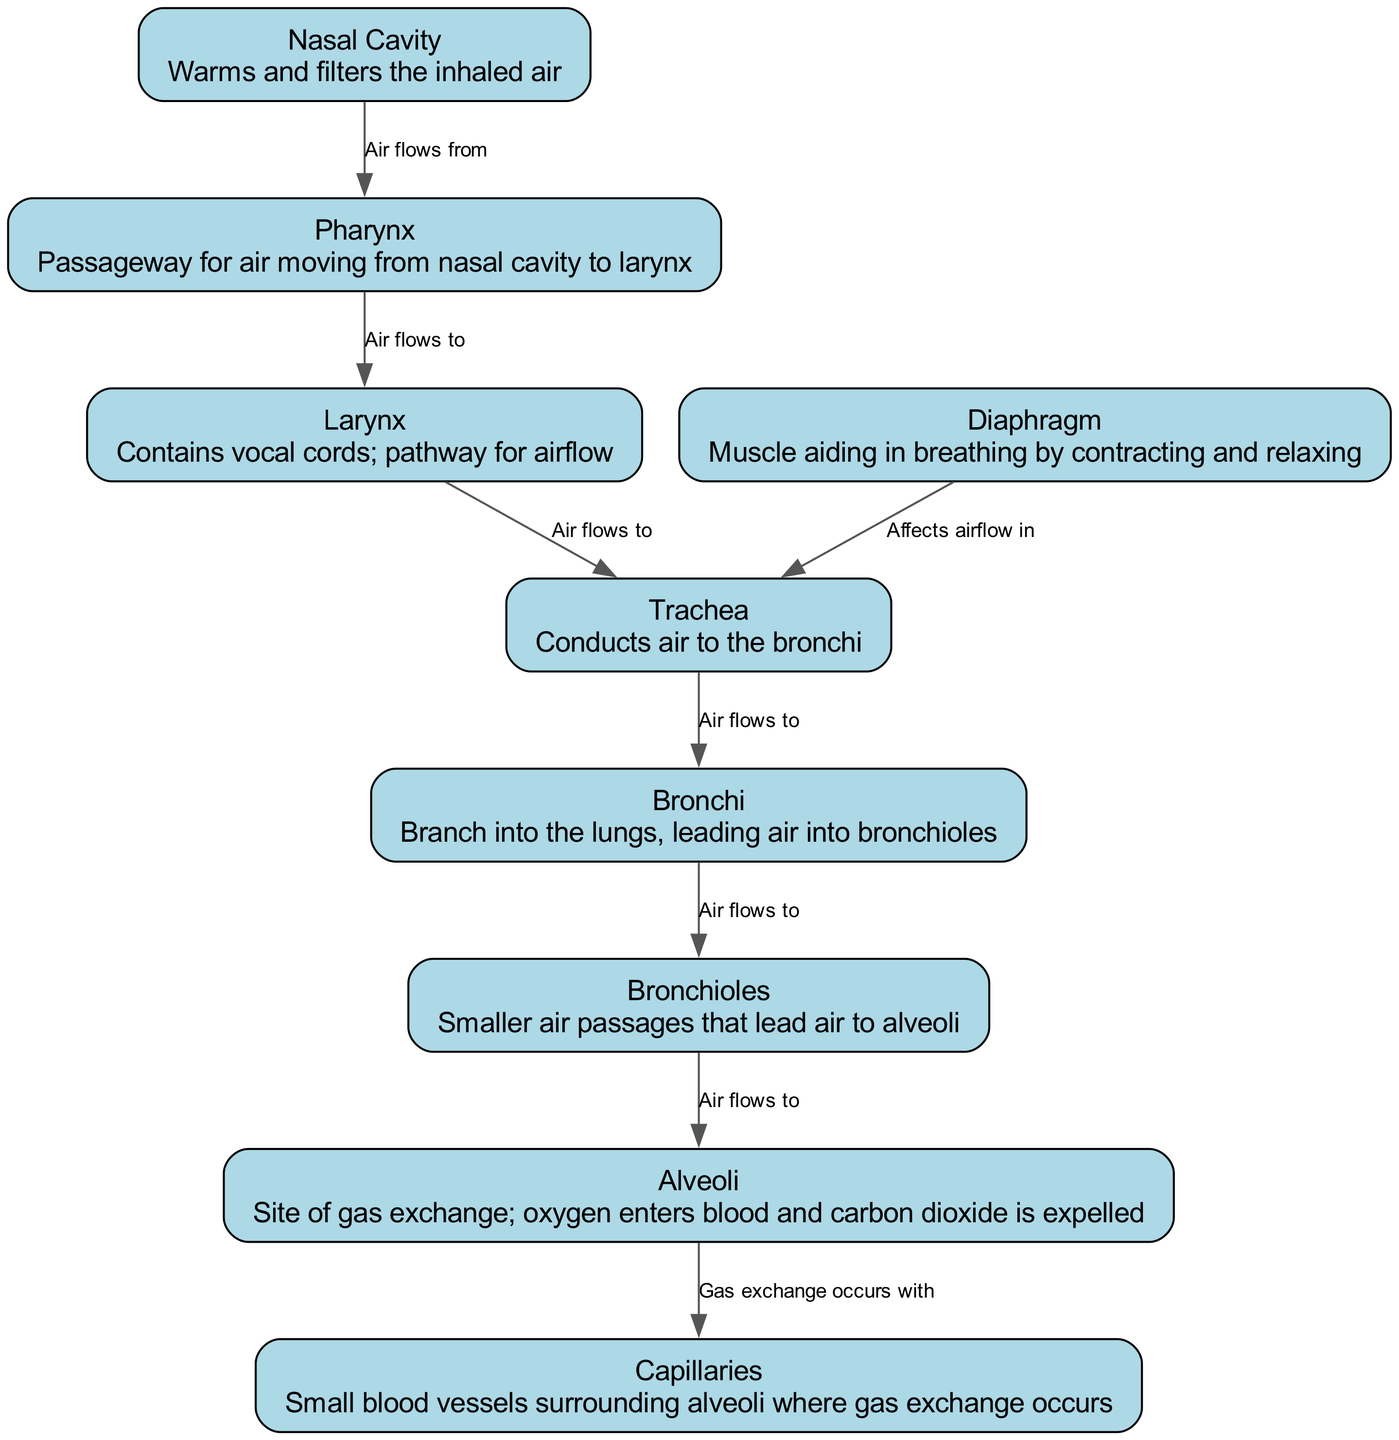What is the function of the Nasal Cavity? The Nasal Cavity's description states that it "warms and filters the inhaled air," which indicates its role in preparing air before it enters the respiratory system.
Answer: Warms and filters the inhaled air How many nodes are present in the diagram? The diagram lists a total of 9 nodes representing different parts of the respiratory system.
Answer: 9 What flows from the Pharynx to the Larynx? The diagram specifies that "air flows to" the Larynx from the Pharynx, indicating that air is the substance that transitions in this direction.
Answer: Air Where does gas exchange occur? According to the diagram, gas exchange occurs at the Alveoli, as it describes them as the "site of gas exchange."
Answer: Alveoli What muscle aids in breathing by contracting and relaxing? The diagram identifies the Diaphragm as the muscle that plays a significant role in the breathing process through its contraction and relaxation.
Answer: Diaphragm What is the relationship between Alveoli and Capillaries? The diagram states that gas exchange occurs with the Capillaries at the Alveoli, which highlights the direct functional relationship in the gas exchange process.
Answer: Gas exchange occurs with Which structure conducts air to the Bronchi? The diagram indicates that the Trachea is responsible for conducting air to the Bronchi, highlighting its role in the airflow pathway.
Answer: Trachea In what direction does air flow from the Bronchioles? The diagram illustrates that air flows from the Bronchioles to the Alveoli, indicating the pathway of air entering the gas exchange sites.
Answer: To the Alveoli What role does the Diaphragm have in the Trachea? The diagram explains that the Diaphragm affects airflow in the Trachea, which ties together the function of the muscle with its effect on the airway.
Answer: Affects airflow in 